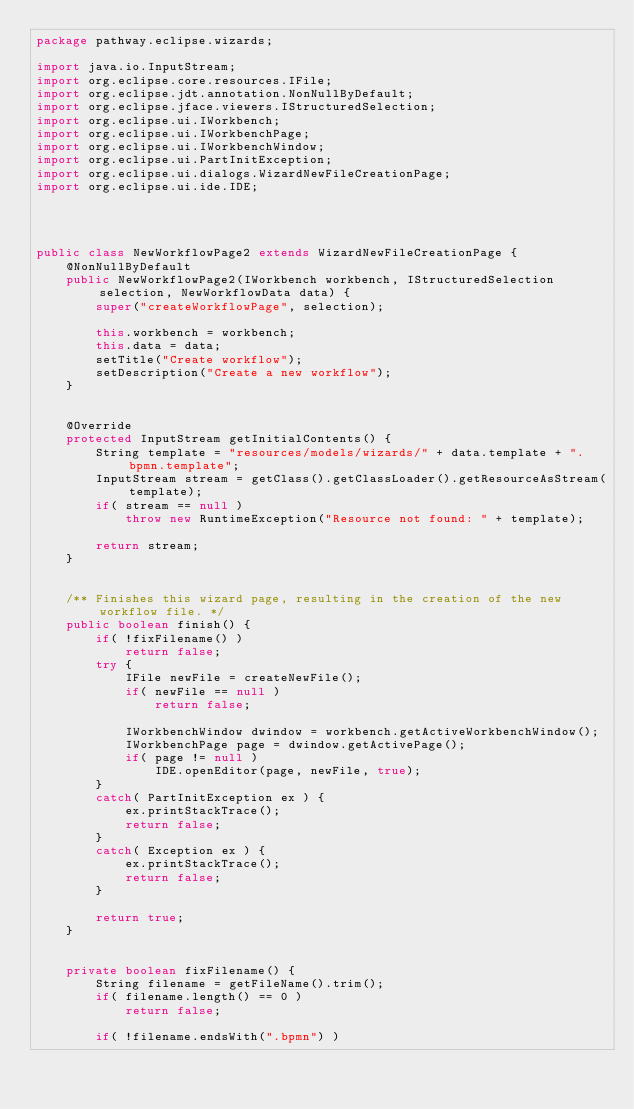Convert code to text. <code><loc_0><loc_0><loc_500><loc_500><_Java_>package pathway.eclipse.wizards;

import java.io.InputStream;
import org.eclipse.core.resources.IFile;
import org.eclipse.jdt.annotation.NonNullByDefault;
import org.eclipse.jface.viewers.IStructuredSelection;
import org.eclipse.ui.IWorkbench;
import org.eclipse.ui.IWorkbenchPage;
import org.eclipse.ui.IWorkbenchWindow;
import org.eclipse.ui.PartInitException;
import org.eclipse.ui.dialogs.WizardNewFileCreationPage;
import org.eclipse.ui.ide.IDE;




public class NewWorkflowPage2 extends WizardNewFileCreationPage {
    @NonNullByDefault
    public NewWorkflowPage2(IWorkbench workbench, IStructuredSelection selection, NewWorkflowData data) {
        super("createWorkflowPage", selection);

        this.workbench = workbench;
        this.data = data;
        setTitle("Create workflow");
        setDescription("Create a new workflow");
    }


    @Override
    protected InputStream getInitialContents() {
        String template = "resources/models/wizards/" + data.template + ".bpmn.template";
        InputStream stream = getClass().getClassLoader().getResourceAsStream(template);
        if( stream == null )
            throw new RuntimeException("Resource not found: " + template);

        return stream;
    }


    /** Finishes this wizard page, resulting in the creation of the new workflow file. */
    public boolean finish() {
        if( !fixFilename() )
            return false;
        try {
            IFile newFile = createNewFile();
            if( newFile == null )
                return false;

            IWorkbenchWindow dwindow = workbench.getActiveWorkbenchWindow();
            IWorkbenchPage page = dwindow.getActivePage();
            if( page != null )
                IDE.openEditor(page, newFile, true);
        }
        catch( PartInitException ex ) {
            ex.printStackTrace();
            return false;
        }
        catch( Exception ex ) {
            ex.printStackTrace();
            return false;
        }

        return true;
    }


    private boolean fixFilename() {
        String filename = getFileName().trim();
        if( filename.length() == 0 )
            return false;

        if( !filename.endsWith(".bpmn") )</code> 